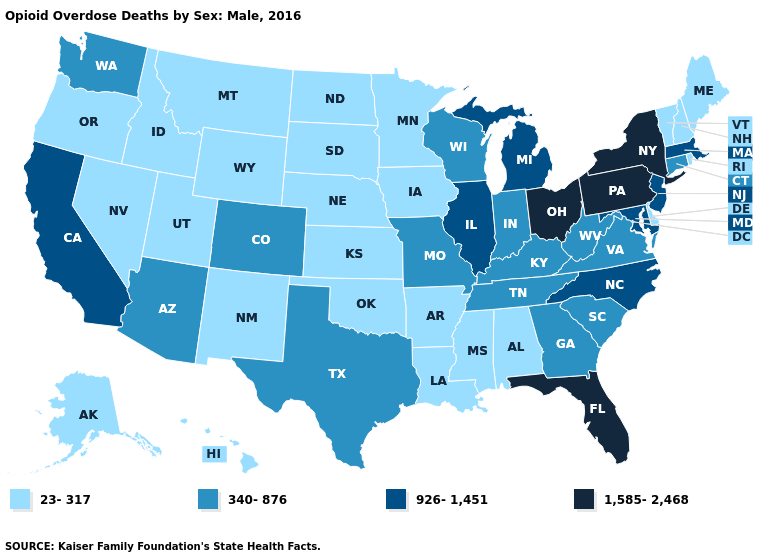Does Delaware have the lowest value in the South?
Answer briefly. Yes. What is the highest value in states that border West Virginia?
Write a very short answer. 1,585-2,468. Among the states that border Illinois , does Iowa have the lowest value?
Answer briefly. Yes. Which states hav the highest value in the Northeast?
Short answer required. New York, Pennsylvania. Among the states that border Rhode Island , does Connecticut have the highest value?
Give a very brief answer. No. What is the value of Illinois?
Answer briefly. 926-1,451. Among the states that border Iowa , does Minnesota have the lowest value?
Quick response, please. Yes. Does Indiana have a higher value than Oregon?
Be succinct. Yes. What is the highest value in states that border Wyoming?
Quick response, please. 340-876. Name the states that have a value in the range 1,585-2,468?
Give a very brief answer. Florida, New York, Ohio, Pennsylvania. Does Wisconsin have the highest value in the USA?
Keep it brief. No. What is the value of Alaska?
Be succinct. 23-317. Does the map have missing data?
Short answer required. No. What is the lowest value in the USA?
Quick response, please. 23-317. Among the states that border Alabama , does Florida have the lowest value?
Write a very short answer. No. 